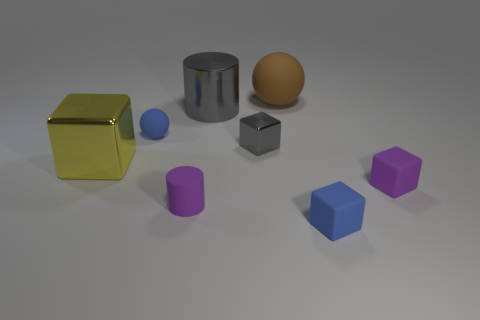Subtract all tiny shiny blocks. How many blocks are left? 3 Subtract 1 blocks. How many blocks are left? 3 Subtract all blue cubes. How many cubes are left? 3 Add 2 green spheres. How many objects exist? 10 Subtract all balls. How many objects are left? 6 Subtract all blue blocks. Subtract all cyan spheres. How many blocks are left? 3 Subtract all metal cubes. Subtract all large gray objects. How many objects are left? 5 Add 3 brown objects. How many brown objects are left? 4 Add 8 tiny gray rubber cylinders. How many tiny gray rubber cylinders exist? 8 Subtract 0 green blocks. How many objects are left? 8 